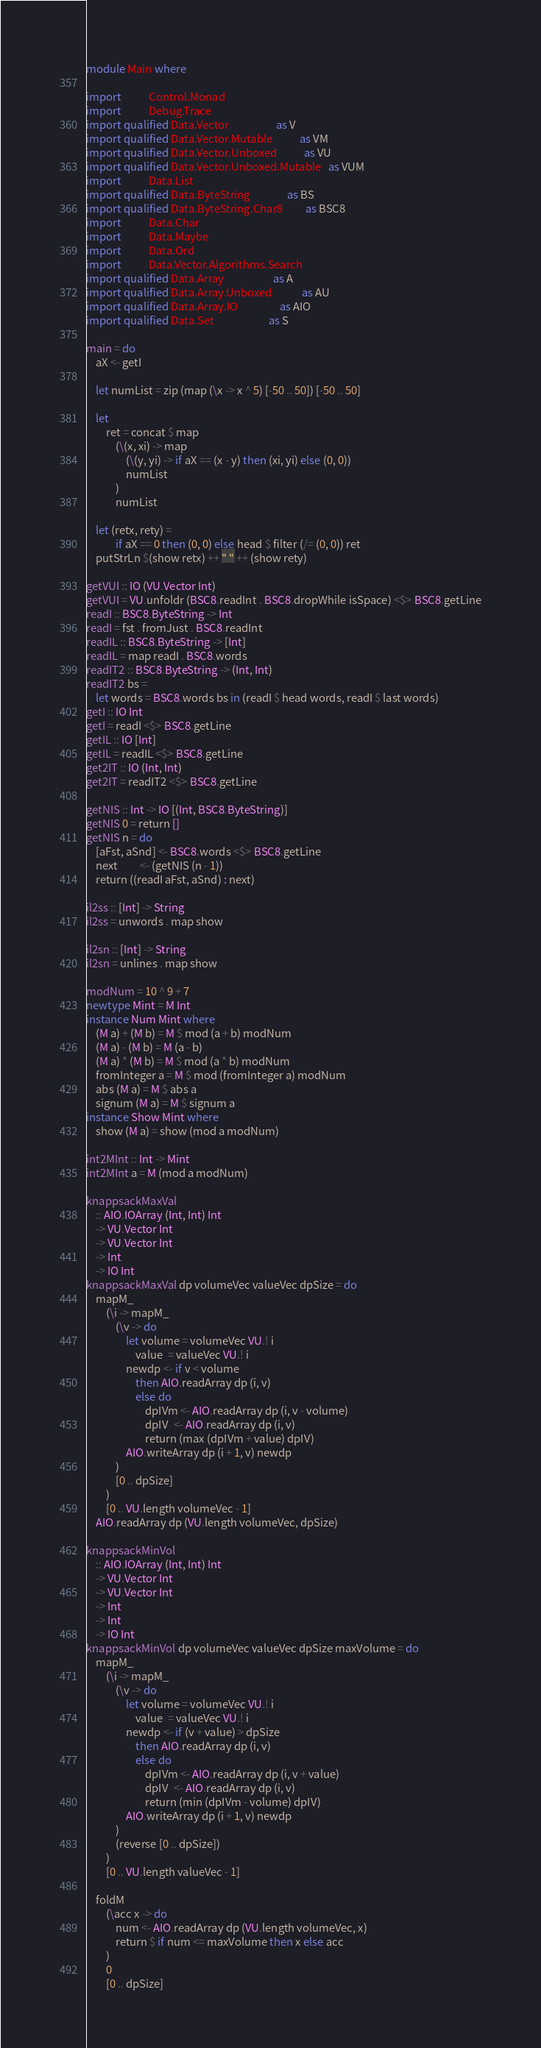<code> <loc_0><loc_0><loc_500><loc_500><_Haskell_>
module Main where

import           Control.Monad
import           Debug.Trace
import qualified Data.Vector                   as V
import qualified Data.Vector.Mutable           as VM
import qualified Data.Vector.Unboxed           as VU
import qualified Data.Vector.Unboxed.Mutable   as VUM
import           Data.List
import qualified Data.ByteString               as BS
import qualified Data.ByteString.Char8         as BSC8
import           Data.Char
import           Data.Maybe
import           Data.Ord
import           Data.Vector.Algorithms.Search
import qualified Data.Array                    as A
import qualified Data.Array.Unboxed            as AU
import qualified Data.Array.IO                 as AIO
import qualified Data.Set                      as S

main = do
    aX <- getI

    let numList = zip (map (\x -> x ^ 5) [-50 .. 50]) [-50 .. 50]

    let
        ret = concat $ map
            (\(x, xi) -> map
                (\(y, yi) -> if aX == (x - y) then (xi, yi) else (0, 0))
                numList
            )
            numList

    let (retx, rety) =
            if aX == 0 then (0, 0) else head $ filter (/= (0, 0)) ret
    putStrLn $(show retx) ++ " " ++ (show rety)

getVUI :: IO (VU.Vector Int)
getVUI = VU.unfoldr (BSC8.readInt . BSC8.dropWhile isSpace) <$> BSC8.getLine
readI :: BSC8.ByteString -> Int
readI = fst . fromJust . BSC8.readInt
readIL :: BSC8.ByteString -> [Int]
readIL = map readI . BSC8.words
readIT2 :: BSC8.ByteString -> (Int, Int)
readIT2 bs =
    let words = BSC8.words bs in (readI $ head words, readI $ last words)
getI :: IO Int
getI = readI <$> BSC8.getLine
getIL :: IO [Int]
getIL = readIL <$> BSC8.getLine
get2IT :: IO (Int, Int)
get2IT = readIT2 <$> BSC8.getLine

getNIS :: Int -> IO [(Int, BSC8.ByteString)]
getNIS 0 = return []
getNIS n = do
    [aFst, aSnd] <- BSC8.words <$> BSC8.getLine
    next         <- (getNIS (n - 1))
    return ((readI aFst, aSnd) : next)

il2ss :: [Int] -> String
il2ss = unwords . map show

il2sn :: [Int] -> String
il2sn = unlines . map show

modNum = 10 ^ 9 + 7
newtype Mint = M Int
instance Num Mint where
    (M a) + (M b) = M $ mod (a + b) modNum
    (M a) - (M b) = M (a - b)
    (M a) * (M b) = M $ mod (a * b) modNum
    fromInteger a = M $ mod (fromInteger a) modNum
    abs (M a) = M $ abs a
    signum (M a) = M $ signum a
instance Show Mint where
    show (M a) = show (mod a modNum)

int2MInt :: Int -> Mint
int2MInt a = M (mod a modNum)

knappsackMaxVal
    :: AIO.IOArray (Int, Int) Int
    -> VU.Vector Int
    -> VU.Vector Int
    -> Int
    -> IO Int
knappsackMaxVal dp volumeVec valueVec dpSize = do
    mapM_
        (\i -> mapM_
            (\v -> do
                let volume = volumeVec VU.! i
                    value  = valueVec VU.! i
                newdp <- if v < volume
                    then AIO.readArray dp (i, v)
                    else do
                        dpIVm <- AIO.readArray dp (i, v - volume)
                        dpIV  <- AIO.readArray dp (i, v)
                        return (max (dpIVm + value) dpIV)
                AIO.writeArray dp (i + 1, v) newdp
            )
            [0 .. dpSize]
        )
        [0 .. VU.length volumeVec - 1]
    AIO.readArray dp (VU.length volumeVec, dpSize)

knappsackMinVol
    :: AIO.IOArray (Int, Int) Int
    -> VU.Vector Int
    -> VU.Vector Int
    -> Int
    -> Int
    -> IO Int
knappsackMinVol dp volumeVec valueVec dpSize maxVolume = do
    mapM_
        (\i -> mapM_
            (\v -> do
                let volume = volumeVec VU.! i
                    value  = valueVec VU.! i
                newdp <- if (v + value) > dpSize
                    then AIO.readArray dp (i, v)
                    else do
                        dpIVm <- AIO.readArray dp (i, v + value)
                        dpIV  <- AIO.readArray dp (i, v)
                        return (min (dpIVm - volume) dpIV)
                AIO.writeArray dp (i + 1, v) newdp
            )
            (reverse [0 .. dpSize])
        )
        [0 .. VU.length valueVec - 1]

    foldM
        (\acc x -> do
            num <- AIO.readArray dp (VU.length volumeVec, x)
            return $ if num <= maxVolume then x else acc
        )
        0
        [0 .. dpSize]

</code> 